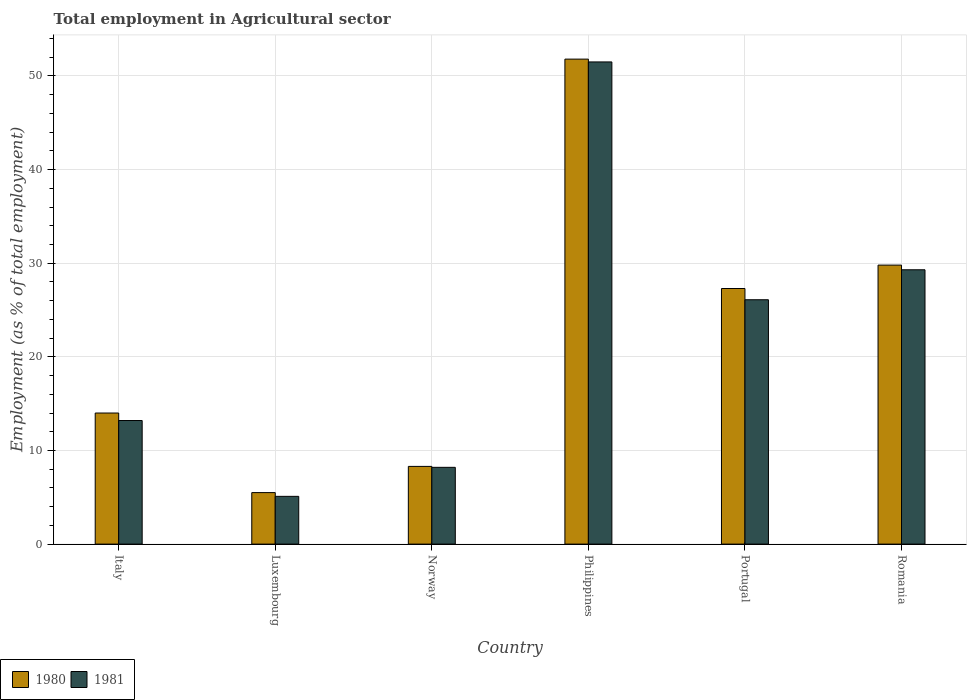How many different coloured bars are there?
Give a very brief answer. 2. How many groups of bars are there?
Your answer should be compact. 6. Are the number of bars per tick equal to the number of legend labels?
Your answer should be compact. Yes. How many bars are there on the 3rd tick from the left?
Make the answer very short. 2. What is the label of the 3rd group of bars from the left?
Keep it short and to the point. Norway. In how many cases, is the number of bars for a given country not equal to the number of legend labels?
Provide a succinct answer. 0. What is the employment in agricultural sector in 1980 in Norway?
Ensure brevity in your answer.  8.3. Across all countries, what is the maximum employment in agricultural sector in 1981?
Keep it short and to the point. 51.5. Across all countries, what is the minimum employment in agricultural sector in 1981?
Ensure brevity in your answer.  5.1. In which country was the employment in agricultural sector in 1981 minimum?
Your answer should be very brief. Luxembourg. What is the total employment in agricultural sector in 1981 in the graph?
Provide a short and direct response. 133.4. What is the difference between the employment in agricultural sector in 1981 in Luxembourg and that in Norway?
Provide a short and direct response. -3.1. What is the average employment in agricultural sector in 1981 per country?
Offer a very short reply. 22.23. What is the difference between the employment in agricultural sector of/in 1980 and employment in agricultural sector of/in 1981 in Portugal?
Ensure brevity in your answer.  1.2. What is the ratio of the employment in agricultural sector in 1981 in Luxembourg to that in Romania?
Your answer should be very brief. 0.17. What is the difference between the highest and the second highest employment in agricultural sector in 1980?
Offer a terse response. -24.5. What is the difference between the highest and the lowest employment in agricultural sector in 1980?
Give a very brief answer. 46.3. Are all the bars in the graph horizontal?
Provide a short and direct response. No. How many countries are there in the graph?
Your answer should be compact. 6. What is the difference between two consecutive major ticks on the Y-axis?
Provide a succinct answer. 10. Does the graph contain any zero values?
Ensure brevity in your answer.  No. Where does the legend appear in the graph?
Provide a succinct answer. Bottom left. How many legend labels are there?
Your answer should be very brief. 2. What is the title of the graph?
Your answer should be compact. Total employment in Agricultural sector. Does "2002" appear as one of the legend labels in the graph?
Provide a succinct answer. No. What is the label or title of the Y-axis?
Ensure brevity in your answer.  Employment (as % of total employment). What is the Employment (as % of total employment) in 1980 in Italy?
Ensure brevity in your answer.  14. What is the Employment (as % of total employment) in 1981 in Italy?
Your answer should be compact. 13.2. What is the Employment (as % of total employment) in 1981 in Luxembourg?
Offer a terse response. 5.1. What is the Employment (as % of total employment) of 1980 in Norway?
Give a very brief answer. 8.3. What is the Employment (as % of total employment) in 1981 in Norway?
Give a very brief answer. 8.2. What is the Employment (as % of total employment) of 1980 in Philippines?
Offer a very short reply. 51.8. What is the Employment (as % of total employment) of 1981 in Philippines?
Give a very brief answer. 51.5. What is the Employment (as % of total employment) in 1980 in Portugal?
Keep it short and to the point. 27.3. What is the Employment (as % of total employment) in 1981 in Portugal?
Your answer should be compact. 26.1. What is the Employment (as % of total employment) in 1980 in Romania?
Provide a succinct answer. 29.8. What is the Employment (as % of total employment) in 1981 in Romania?
Your answer should be compact. 29.3. Across all countries, what is the maximum Employment (as % of total employment) in 1980?
Offer a terse response. 51.8. Across all countries, what is the maximum Employment (as % of total employment) in 1981?
Offer a very short reply. 51.5. Across all countries, what is the minimum Employment (as % of total employment) of 1980?
Keep it short and to the point. 5.5. Across all countries, what is the minimum Employment (as % of total employment) of 1981?
Provide a short and direct response. 5.1. What is the total Employment (as % of total employment) in 1980 in the graph?
Provide a short and direct response. 136.7. What is the total Employment (as % of total employment) in 1981 in the graph?
Offer a terse response. 133.4. What is the difference between the Employment (as % of total employment) of 1981 in Italy and that in Luxembourg?
Keep it short and to the point. 8.1. What is the difference between the Employment (as % of total employment) of 1980 in Italy and that in Philippines?
Ensure brevity in your answer.  -37.8. What is the difference between the Employment (as % of total employment) of 1981 in Italy and that in Philippines?
Your response must be concise. -38.3. What is the difference between the Employment (as % of total employment) in 1980 in Italy and that in Portugal?
Keep it short and to the point. -13.3. What is the difference between the Employment (as % of total employment) in 1981 in Italy and that in Portugal?
Your response must be concise. -12.9. What is the difference between the Employment (as % of total employment) of 1980 in Italy and that in Romania?
Offer a very short reply. -15.8. What is the difference between the Employment (as % of total employment) in 1981 in Italy and that in Romania?
Provide a short and direct response. -16.1. What is the difference between the Employment (as % of total employment) of 1981 in Luxembourg and that in Norway?
Offer a very short reply. -3.1. What is the difference between the Employment (as % of total employment) in 1980 in Luxembourg and that in Philippines?
Offer a very short reply. -46.3. What is the difference between the Employment (as % of total employment) in 1981 in Luxembourg and that in Philippines?
Your response must be concise. -46.4. What is the difference between the Employment (as % of total employment) of 1980 in Luxembourg and that in Portugal?
Offer a very short reply. -21.8. What is the difference between the Employment (as % of total employment) in 1980 in Luxembourg and that in Romania?
Your answer should be compact. -24.3. What is the difference between the Employment (as % of total employment) of 1981 in Luxembourg and that in Romania?
Keep it short and to the point. -24.2. What is the difference between the Employment (as % of total employment) in 1980 in Norway and that in Philippines?
Provide a short and direct response. -43.5. What is the difference between the Employment (as % of total employment) of 1981 in Norway and that in Philippines?
Keep it short and to the point. -43.3. What is the difference between the Employment (as % of total employment) in 1981 in Norway and that in Portugal?
Your response must be concise. -17.9. What is the difference between the Employment (as % of total employment) of 1980 in Norway and that in Romania?
Give a very brief answer. -21.5. What is the difference between the Employment (as % of total employment) in 1981 in Norway and that in Romania?
Your answer should be very brief. -21.1. What is the difference between the Employment (as % of total employment) in 1981 in Philippines and that in Portugal?
Your answer should be very brief. 25.4. What is the difference between the Employment (as % of total employment) in 1981 in Philippines and that in Romania?
Make the answer very short. 22.2. What is the difference between the Employment (as % of total employment) in 1981 in Portugal and that in Romania?
Offer a very short reply. -3.2. What is the difference between the Employment (as % of total employment) in 1980 in Italy and the Employment (as % of total employment) in 1981 in Norway?
Your response must be concise. 5.8. What is the difference between the Employment (as % of total employment) of 1980 in Italy and the Employment (as % of total employment) of 1981 in Philippines?
Offer a terse response. -37.5. What is the difference between the Employment (as % of total employment) of 1980 in Italy and the Employment (as % of total employment) of 1981 in Romania?
Give a very brief answer. -15.3. What is the difference between the Employment (as % of total employment) in 1980 in Luxembourg and the Employment (as % of total employment) in 1981 in Philippines?
Provide a succinct answer. -46. What is the difference between the Employment (as % of total employment) of 1980 in Luxembourg and the Employment (as % of total employment) of 1981 in Portugal?
Give a very brief answer. -20.6. What is the difference between the Employment (as % of total employment) of 1980 in Luxembourg and the Employment (as % of total employment) of 1981 in Romania?
Provide a succinct answer. -23.8. What is the difference between the Employment (as % of total employment) of 1980 in Norway and the Employment (as % of total employment) of 1981 in Philippines?
Your response must be concise. -43.2. What is the difference between the Employment (as % of total employment) in 1980 in Norway and the Employment (as % of total employment) in 1981 in Portugal?
Your answer should be very brief. -17.8. What is the difference between the Employment (as % of total employment) of 1980 in Norway and the Employment (as % of total employment) of 1981 in Romania?
Your answer should be compact. -21. What is the difference between the Employment (as % of total employment) in 1980 in Philippines and the Employment (as % of total employment) in 1981 in Portugal?
Your response must be concise. 25.7. What is the difference between the Employment (as % of total employment) of 1980 in Portugal and the Employment (as % of total employment) of 1981 in Romania?
Your answer should be very brief. -2. What is the average Employment (as % of total employment) in 1980 per country?
Give a very brief answer. 22.78. What is the average Employment (as % of total employment) in 1981 per country?
Give a very brief answer. 22.23. What is the difference between the Employment (as % of total employment) in 1980 and Employment (as % of total employment) in 1981 in Italy?
Your response must be concise. 0.8. What is the difference between the Employment (as % of total employment) of 1980 and Employment (as % of total employment) of 1981 in Luxembourg?
Make the answer very short. 0.4. What is the difference between the Employment (as % of total employment) in 1980 and Employment (as % of total employment) in 1981 in Philippines?
Ensure brevity in your answer.  0.3. What is the difference between the Employment (as % of total employment) in 1980 and Employment (as % of total employment) in 1981 in Portugal?
Your response must be concise. 1.2. What is the ratio of the Employment (as % of total employment) of 1980 in Italy to that in Luxembourg?
Your answer should be very brief. 2.55. What is the ratio of the Employment (as % of total employment) of 1981 in Italy to that in Luxembourg?
Make the answer very short. 2.59. What is the ratio of the Employment (as % of total employment) in 1980 in Italy to that in Norway?
Your answer should be compact. 1.69. What is the ratio of the Employment (as % of total employment) in 1981 in Italy to that in Norway?
Give a very brief answer. 1.61. What is the ratio of the Employment (as % of total employment) in 1980 in Italy to that in Philippines?
Your answer should be very brief. 0.27. What is the ratio of the Employment (as % of total employment) of 1981 in Italy to that in Philippines?
Offer a very short reply. 0.26. What is the ratio of the Employment (as % of total employment) of 1980 in Italy to that in Portugal?
Your answer should be compact. 0.51. What is the ratio of the Employment (as % of total employment) in 1981 in Italy to that in Portugal?
Your answer should be compact. 0.51. What is the ratio of the Employment (as % of total employment) in 1980 in Italy to that in Romania?
Your answer should be very brief. 0.47. What is the ratio of the Employment (as % of total employment) of 1981 in Italy to that in Romania?
Make the answer very short. 0.45. What is the ratio of the Employment (as % of total employment) of 1980 in Luxembourg to that in Norway?
Give a very brief answer. 0.66. What is the ratio of the Employment (as % of total employment) of 1981 in Luxembourg to that in Norway?
Make the answer very short. 0.62. What is the ratio of the Employment (as % of total employment) of 1980 in Luxembourg to that in Philippines?
Make the answer very short. 0.11. What is the ratio of the Employment (as % of total employment) in 1981 in Luxembourg to that in Philippines?
Your answer should be very brief. 0.1. What is the ratio of the Employment (as % of total employment) of 1980 in Luxembourg to that in Portugal?
Your answer should be very brief. 0.2. What is the ratio of the Employment (as % of total employment) in 1981 in Luxembourg to that in Portugal?
Your answer should be compact. 0.2. What is the ratio of the Employment (as % of total employment) in 1980 in Luxembourg to that in Romania?
Make the answer very short. 0.18. What is the ratio of the Employment (as % of total employment) in 1981 in Luxembourg to that in Romania?
Offer a terse response. 0.17. What is the ratio of the Employment (as % of total employment) in 1980 in Norway to that in Philippines?
Provide a succinct answer. 0.16. What is the ratio of the Employment (as % of total employment) of 1981 in Norway to that in Philippines?
Make the answer very short. 0.16. What is the ratio of the Employment (as % of total employment) of 1980 in Norway to that in Portugal?
Your answer should be compact. 0.3. What is the ratio of the Employment (as % of total employment) in 1981 in Norway to that in Portugal?
Make the answer very short. 0.31. What is the ratio of the Employment (as % of total employment) of 1980 in Norway to that in Romania?
Offer a very short reply. 0.28. What is the ratio of the Employment (as % of total employment) in 1981 in Norway to that in Romania?
Provide a succinct answer. 0.28. What is the ratio of the Employment (as % of total employment) in 1980 in Philippines to that in Portugal?
Your response must be concise. 1.9. What is the ratio of the Employment (as % of total employment) of 1981 in Philippines to that in Portugal?
Ensure brevity in your answer.  1.97. What is the ratio of the Employment (as % of total employment) of 1980 in Philippines to that in Romania?
Offer a terse response. 1.74. What is the ratio of the Employment (as % of total employment) in 1981 in Philippines to that in Romania?
Ensure brevity in your answer.  1.76. What is the ratio of the Employment (as % of total employment) of 1980 in Portugal to that in Romania?
Provide a short and direct response. 0.92. What is the ratio of the Employment (as % of total employment) of 1981 in Portugal to that in Romania?
Provide a short and direct response. 0.89. What is the difference between the highest and the second highest Employment (as % of total employment) in 1980?
Ensure brevity in your answer.  22. What is the difference between the highest and the second highest Employment (as % of total employment) in 1981?
Ensure brevity in your answer.  22.2. What is the difference between the highest and the lowest Employment (as % of total employment) in 1980?
Offer a very short reply. 46.3. What is the difference between the highest and the lowest Employment (as % of total employment) of 1981?
Offer a terse response. 46.4. 